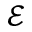Convert formula to latex. <formula><loc_0><loc_0><loc_500><loc_500>\mathcal { E }</formula> 